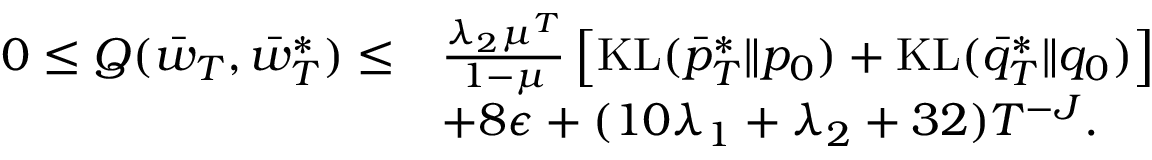Convert formula to latex. <formula><loc_0><loc_0><loc_500><loc_500>\begin{array} { r l } { 0 \leq Q ( \ B a r { w } _ { T } , \bar { w } _ { T } ^ { * } ) \leq } & { \frac { \lambda _ { 2 } \mu ^ { T } } { 1 - \mu } \left [ K L ( \bar { p } _ { T } ^ { * } \| p _ { 0 } ) + K L ( \bar { q } _ { T } ^ { * } \| q _ { 0 } ) \right ] } \\ & { + 8 \epsilon + ( 1 0 \lambda _ { 1 } + \lambda _ { 2 } + 3 2 ) T ^ { - J } . } \end{array}</formula> 